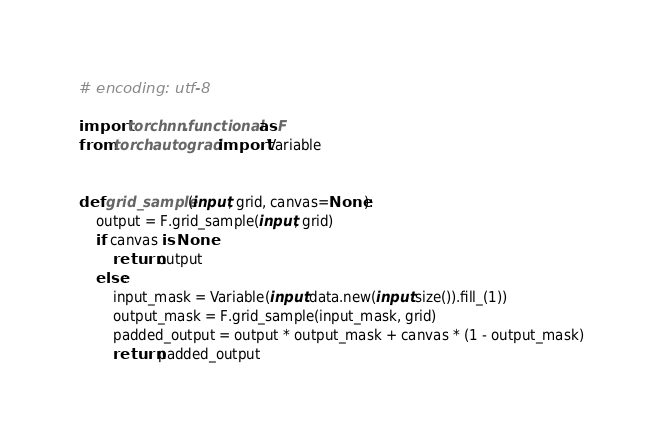<code> <loc_0><loc_0><loc_500><loc_500><_Python_># encoding: utf-8

import torch.nn.functional as F
from torch.autograd import Variable


def grid_sample(input, grid, canvas=None):
    output = F.grid_sample(input, grid)
    if canvas is None:
        return output
    else:
        input_mask = Variable(input.data.new(input.size()).fill_(1))
        output_mask = F.grid_sample(input_mask, grid)
        padded_output = output * output_mask + canvas * (1 - output_mask)
        return padded_output
</code> 